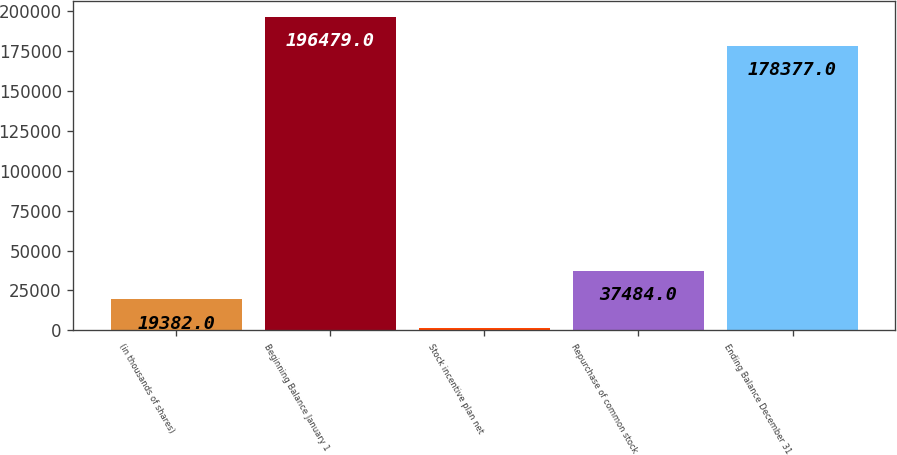<chart> <loc_0><loc_0><loc_500><loc_500><bar_chart><fcel>(in thousands of shares)<fcel>Beginning Balance January 1<fcel>Stock incentive plan net<fcel>Repurchase of common stock<fcel>Ending Balance December 31<nl><fcel>19382<fcel>196479<fcel>1280<fcel>37484<fcel>178377<nl></chart> 